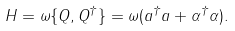Convert formula to latex. <formula><loc_0><loc_0><loc_500><loc_500>H = { \omega } \{ Q , Q ^ { \dagger } \} = { \omega } ( a ^ { \dagger } a + \alpha ^ { \dagger } \alpha ) .</formula> 